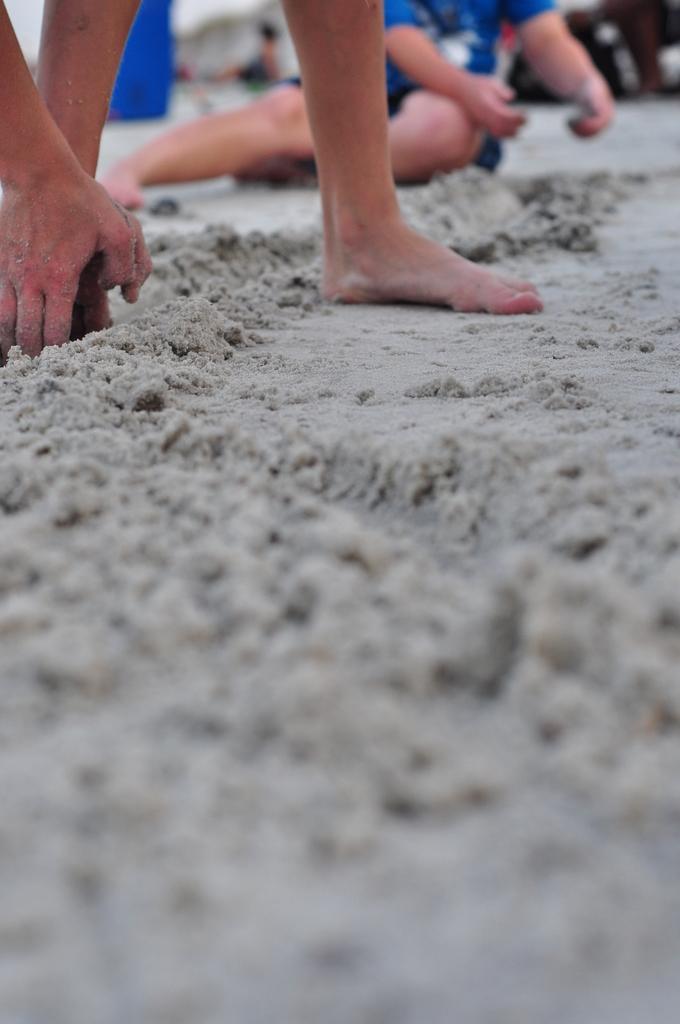Could you give a brief overview of what you see in this image? In this picture we can see people legs and hands and we can see sand. In the background of the image it is blurry and there is a person sitting. 